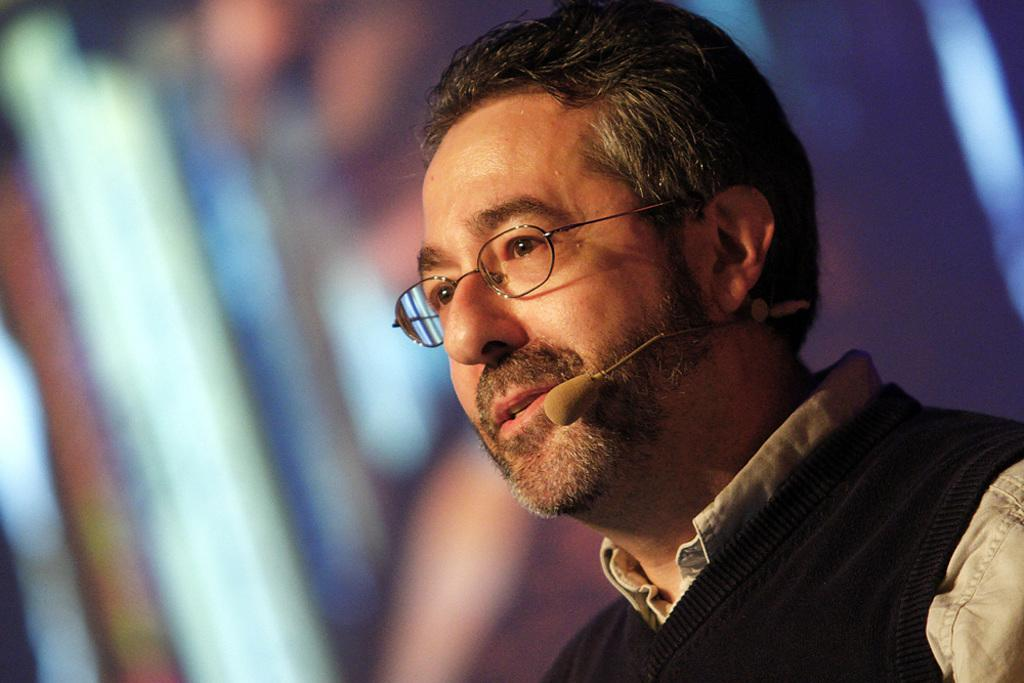Who is present in the image? There is a man in the image. Where is the man located in the image? The man is on the right side of the image. What is the man wearing in the image? The man is wearing a sweater and a shirt. What object can be seen in the image besides the man? There is a microphone (mic) in the image. What type of boot is the man wearing in the image? The man is not wearing any boots in the image; he is wearing a sweater and a shirt. 